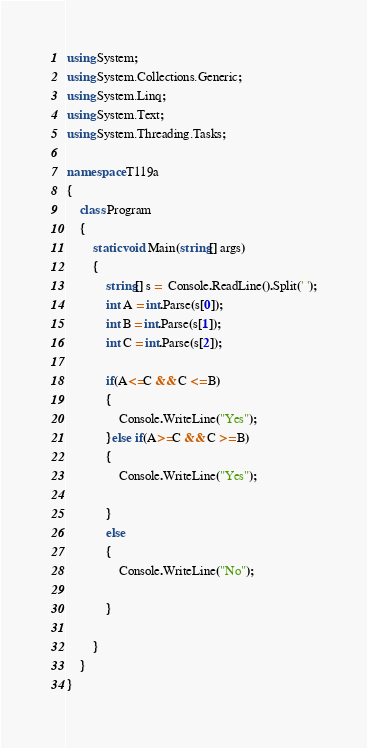Convert code to text. <code><loc_0><loc_0><loc_500><loc_500><_C#_>using System;
using System.Collections.Generic;
using System.Linq;
using System.Text;
using System.Threading.Tasks;

namespace T119a
{
    class Program
    {
        static void Main(string[] args)
        {
            string[] s =  Console.ReadLine().Split(' ');
            int A = int.Parse(s[0]);
            int B = int.Parse(s[1]);
            int C = int.Parse(s[2]);

            if(A<=C && C <= B)
            {
                Console.WriteLine("Yes");
            }else if(A>=C && C >= B)
            {
                Console.WriteLine("Yes");

            }
            else
            {
                Console.WriteLine("No");

            }

        }
    }
}
</code> 